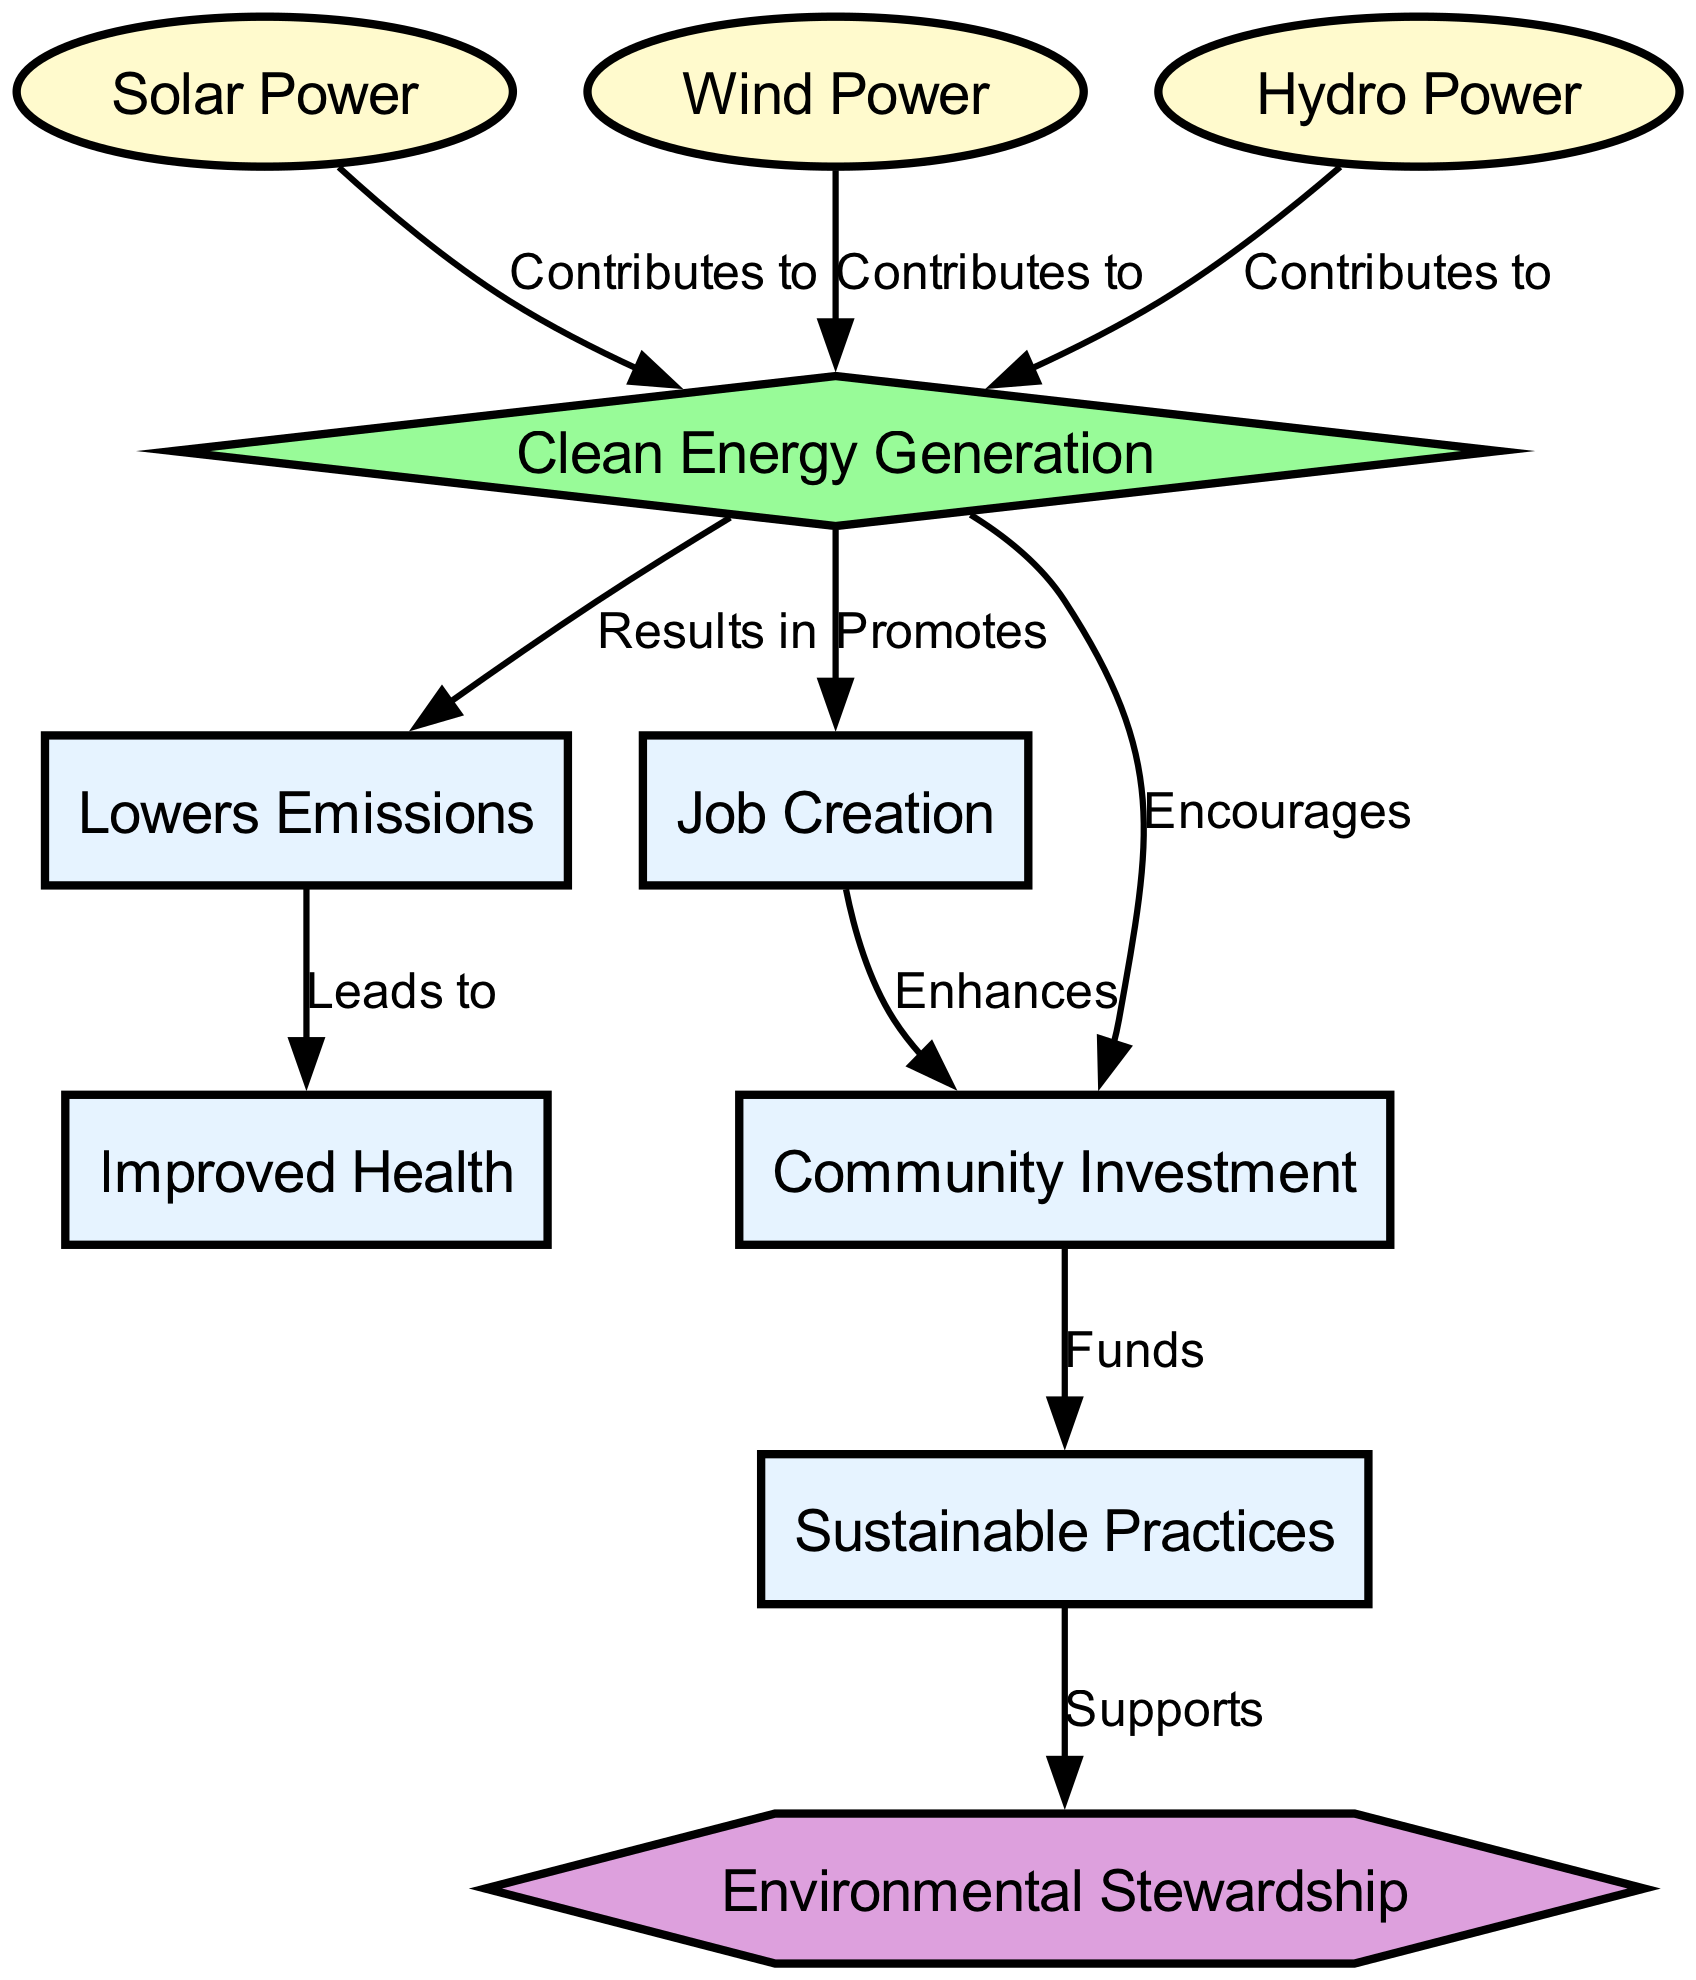What are the three types of power sources mentioned in the diagram? The diagram lists "Solar Power," "Wind Power," and "Hydro Power" as the primary types of renewable energy sources contributing to clean energy generation.
Answer: Solar Power, Wind Power, Hydro Power How many edges are there in the diagram? To determine the number of edges, I count each connection between nodes. There are a total of 9 edges in the diagram connecting various nodes.
Answer: 9 What does clean energy generation promote? The diagram shows that "clean energy generation" promotes both "job creation" and "community investment" directly as indicated by the edges leading to these nodes.
Answer: Job Creation, Community Investment Which node leads to improved health? Following the flow from the "lowers emissions" node leads to the "improved health" node. This indicates that lower emissions result in better health outcomes in the community.
Answer: Improved Health How does community investment support environmental stewardship? The flow indicates that "community investment" funds "sustainable practices," which in turn support "environmental stewardship." This indicates a sequential relationship where community investment directly contributes to better environmental management.
Answer: Supports What does lowering emissions lead to? The diagram shows that lowering emissions leads to improved health, clearly indicated by the directed flow from "lowers emissions" to "improved health."
Answer: Improved Health What is the role of sustainable practices in the diagram? In the diagram, "sustainable practices" support "environmental stewardship," highlighting their importance in promoting environmentally responsible behavior within the community.
Answer: Supports Which node enhances community investment? The diagram indicates that "job creation" enhances "community investment," as there is a direct connection from "job creation" to "community investment."
Answer: Enhances 